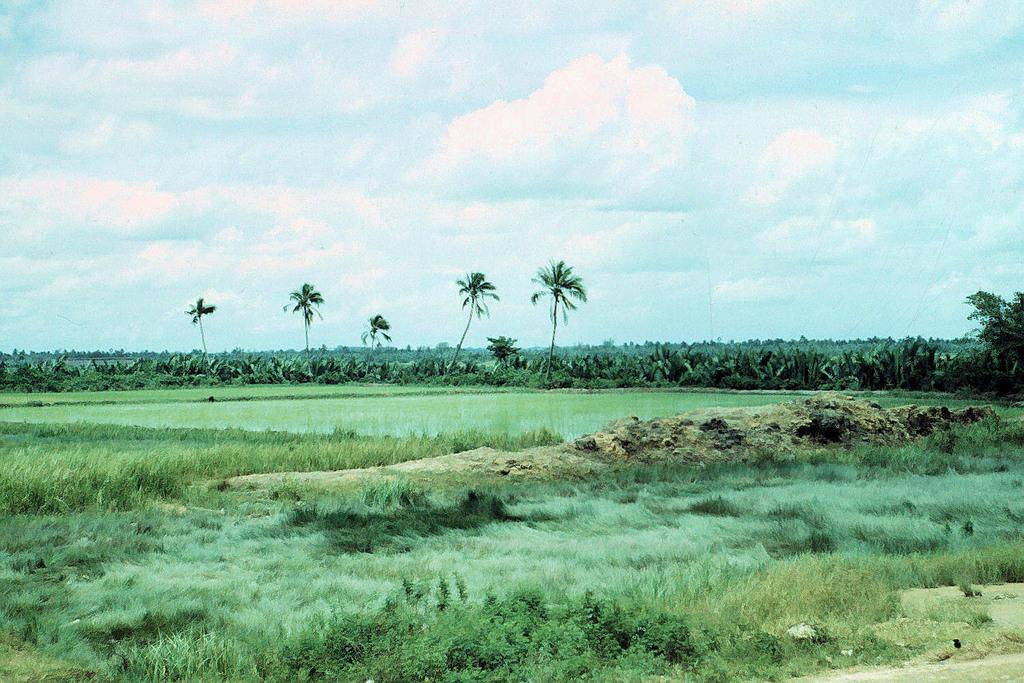What type of vegetation can be seen in the image? There are plants, trees, and grass in the image. Can you describe the sky in the image? The sky is cloudy in the image. What type of shoes can be seen running in the image? There are no shoes or running depicted in the image; it features plants, trees, grass, and a cloudy sky. 